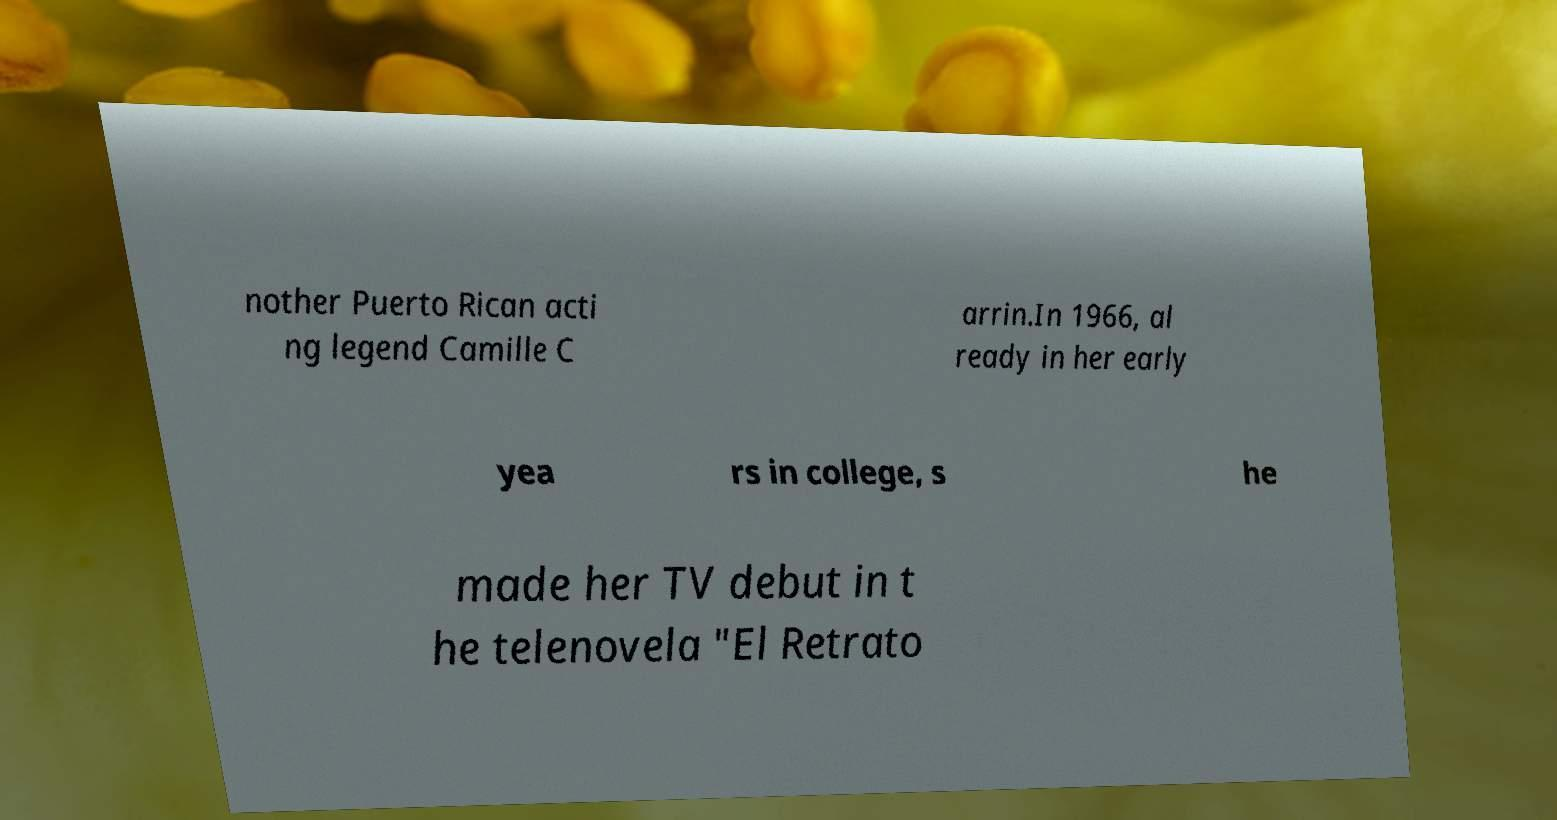There's text embedded in this image that I need extracted. Can you transcribe it verbatim? nother Puerto Rican acti ng legend Camille C arrin.In 1966, al ready in her early yea rs in college, s he made her TV debut in t he telenovela "El Retrato 